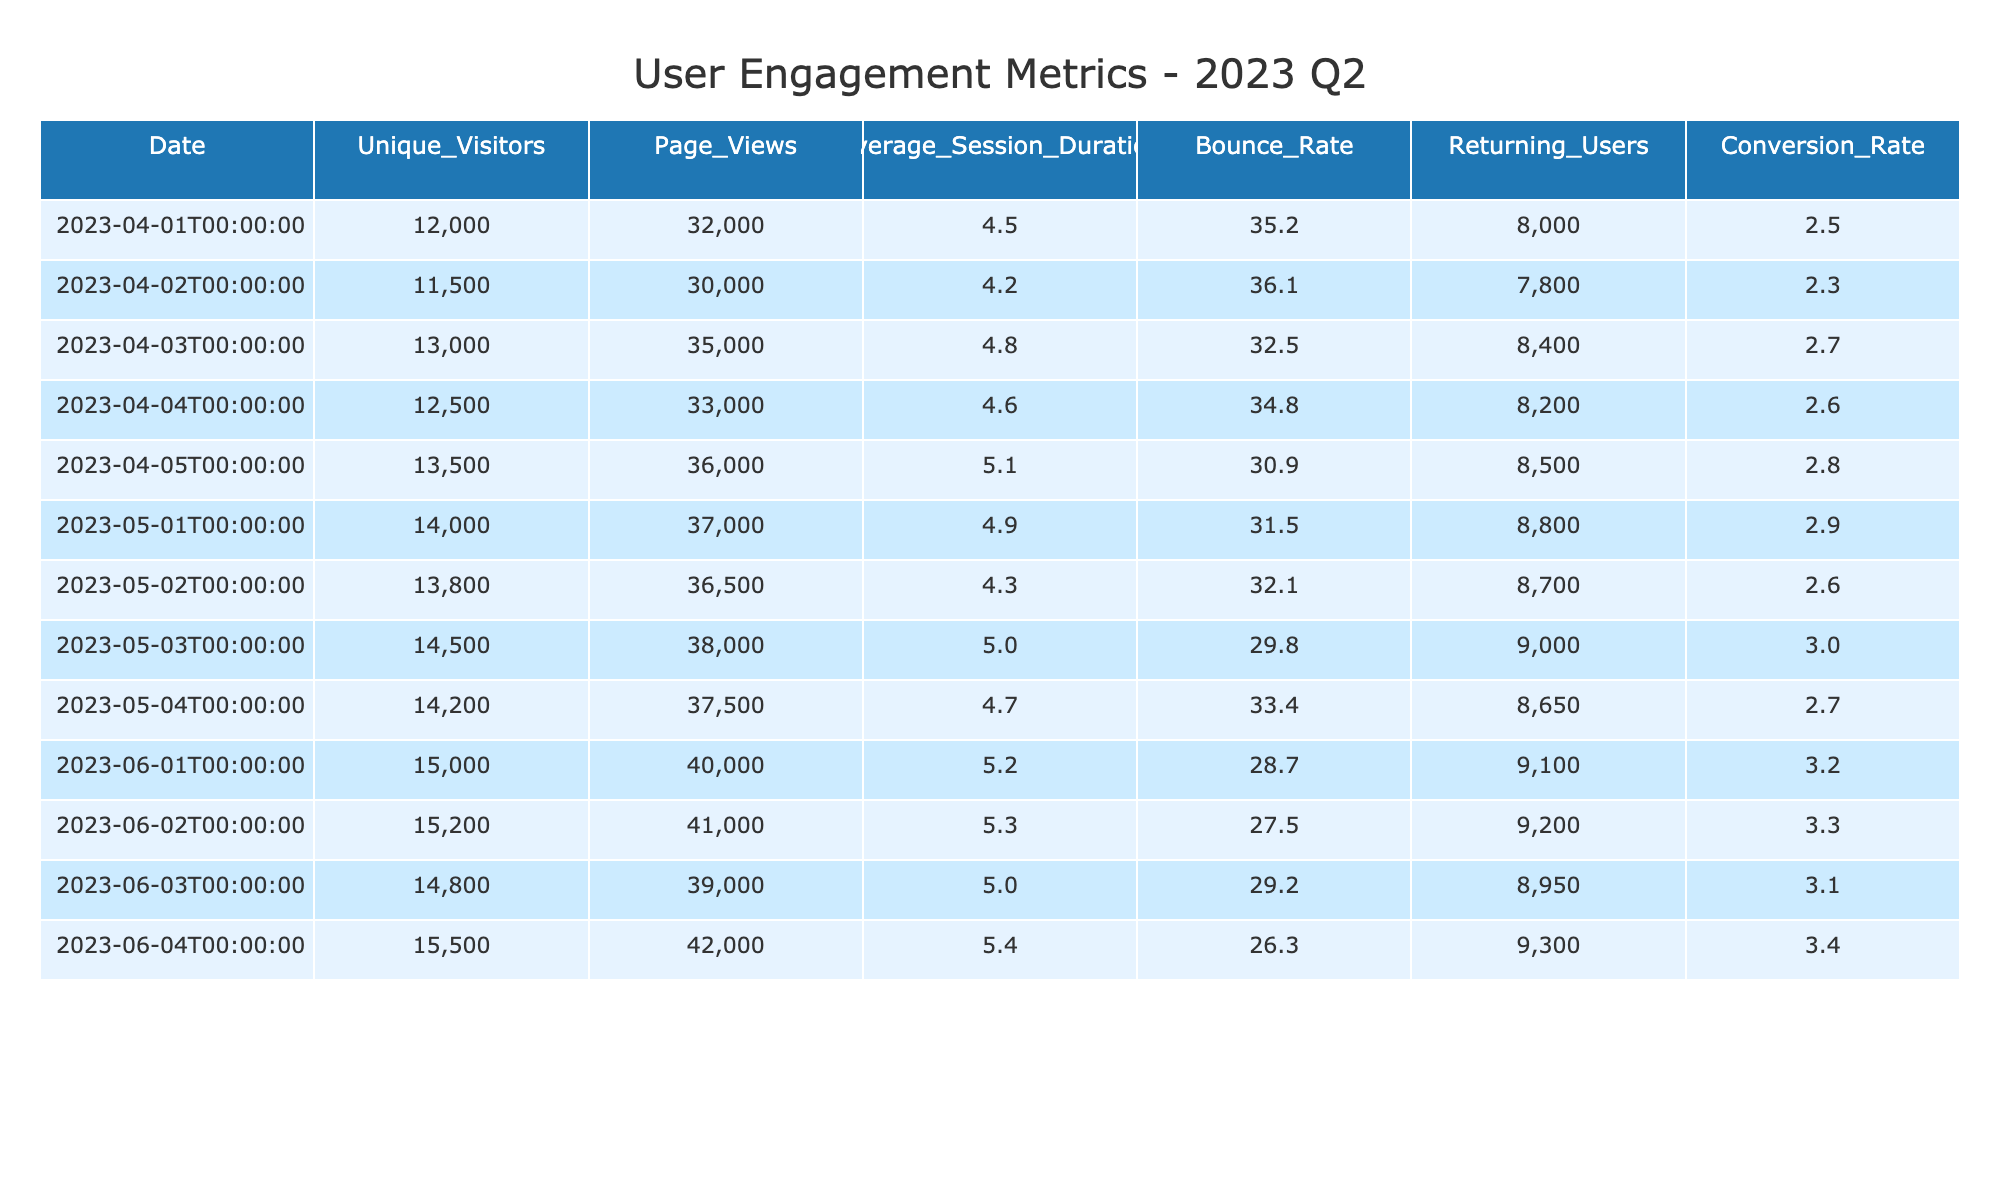What was the highest number of unique visitors in a single day during Q2 2023? Looking through the "Unique_Visitors" column, the highest value is 15,500 on June 4, 2023.
Answer: 15,500 What is the average bounce rate for the entire Q2 2023? To find the average, we sum all the bounce rates (35.2 + 36.1 + 32.5 + 34.8 + 30.9 + 31.5 + 32.1 + 29.8 + 28.7 + 27.5 + 29.2 + 26.3 = 373.5) and divide by the number of days (12). Thus, the average bounce rate is 373.5 / 12 = 31.125.
Answer: 31.1 Is the conversion rate on May 3 higher than the average conversion rate for the month of May? The conversion rate on May 3 is 3.0. For May, we calculate the average of the three data points: (2.9 + 2.6 + 3.0) / 3 = 2.83. Since 3.0 > 2.83, the answer is yes.
Answer: Yes What is the total page views for April 2023? Adding the page views for each date in April yields: (32,000 + 30,000 + 35,000 + 33,000 + 36,000) = 166,000.
Answer: 166,000 On which date was the average session duration the shortest? By examining the "Average_Session_Duration" column, the lowest value is 4.2 on April 2, 2023.
Answer: April 2 What is the difference in unique visitors between the day with the most visitors and the day with the least visitors in June? The maximum unique visitors in June is 15,500 (June 4), and the minimum is 14,800 (June 3). The difference is 15,500 - 14,800 = 700.
Answer: 700 Is the bounce rate generally decreasing over the months from April to June? Checking the average bounce rate per month: April avg = (35.2 + 36.1 + 32.5 + 34.8 + 30.9) / 5 = 33.9; May avg = (31.5 + 32.1 + 29.8) / 3 = 31.13; June avg = (28.7 + 27.5 + 29.2 + 26.3) / 4 = 27.93. Since 33.9 > 31.13 > 27.93, so the answer is yes.
Answer: Yes What was the total number of returning users from April to June? The total returning users is the sum for all days listed: (8000 + 7800 + 8400 + 8200 + 8500 + 8800 + 8700 + 9000 + 9100 + 9200 + 8950 + 9300) = 104,750.
Answer: 104,750 